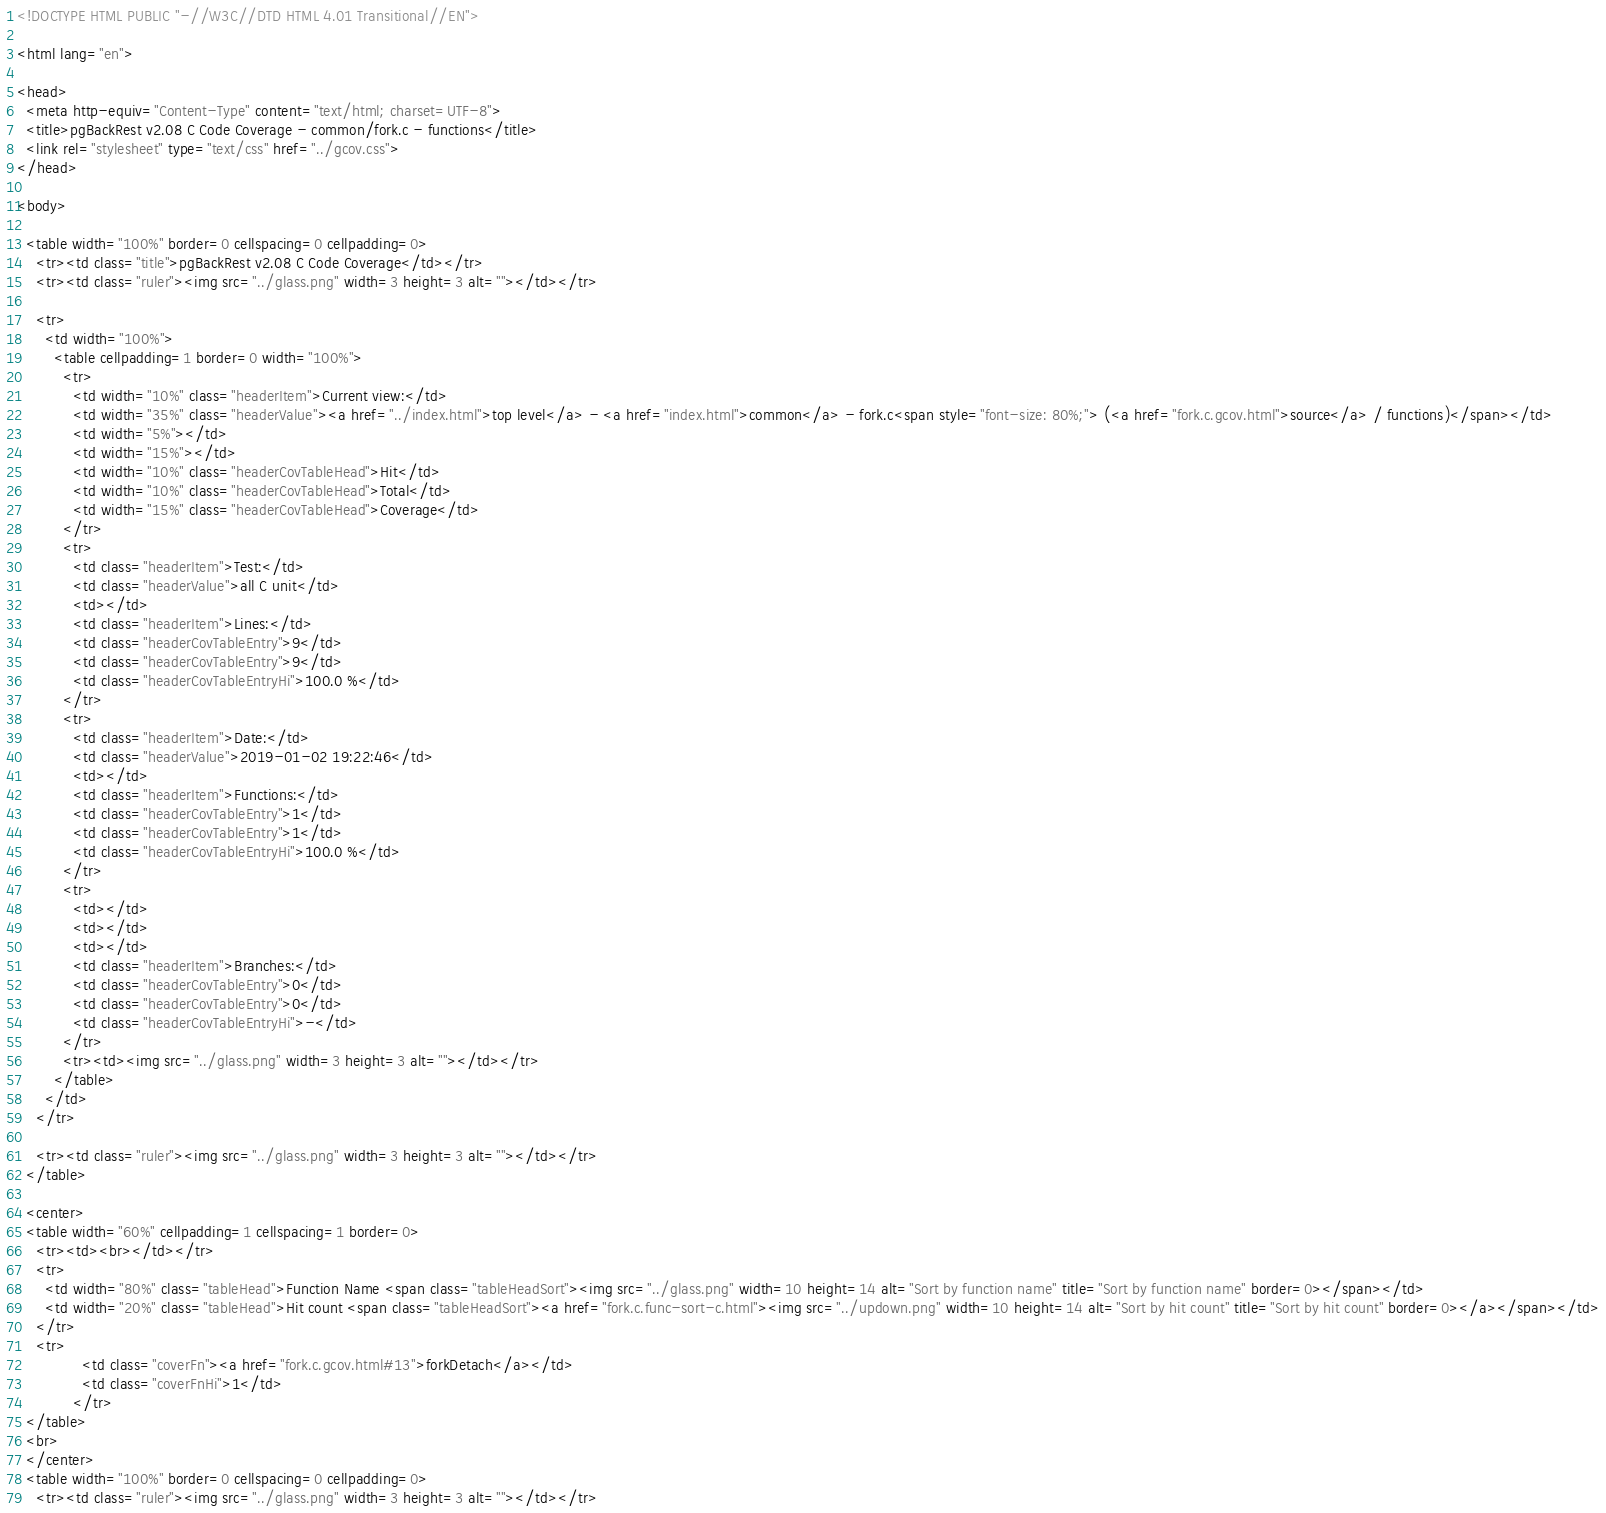Convert code to text. <code><loc_0><loc_0><loc_500><loc_500><_HTML_><!DOCTYPE HTML PUBLIC "-//W3C//DTD HTML 4.01 Transitional//EN">

<html lang="en">

<head>
  <meta http-equiv="Content-Type" content="text/html; charset=UTF-8">
  <title>pgBackRest v2.08 C Code Coverage - common/fork.c - functions</title>
  <link rel="stylesheet" type="text/css" href="../gcov.css">
</head>

<body>

  <table width="100%" border=0 cellspacing=0 cellpadding=0>
    <tr><td class="title">pgBackRest v2.08 C Code Coverage</td></tr>
    <tr><td class="ruler"><img src="../glass.png" width=3 height=3 alt=""></td></tr>

    <tr>
      <td width="100%">
        <table cellpadding=1 border=0 width="100%">
          <tr>
            <td width="10%" class="headerItem">Current view:</td>
            <td width="35%" class="headerValue"><a href="../index.html">top level</a> - <a href="index.html">common</a> - fork.c<span style="font-size: 80%;"> (<a href="fork.c.gcov.html">source</a> / functions)</span></td>
            <td width="5%"></td>
            <td width="15%"></td>
            <td width="10%" class="headerCovTableHead">Hit</td>
            <td width="10%" class="headerCovTableHead">Total</td>
            <td width="15%" class="headerCovTableHead">Coverage</td>
          </tr>
          <tr>
            <td class="headerItem">Test:</td>
            <td class="headerValue">all C unit</td>
            <td></td>
            <td class="headerItem">Lines:</td>
            <td class="headerCovTableEntry">9</td>
            <td class="headerCovTableEntry">9</td>
            <td class="headerCovTableEntryHi">100.0 %</td>
          </tr>
          <tr>
            <td class="headerItem">Date:</td>
            <td class="headerValue">2019-01-02 19:22:46</td>
            <td></td>
            <td class="headerItem">Functions:</td>
            <td class="headerCovTableEntry">1</td>
            <td class="headerCovTableEntry">1</td>
            <td class="headerCovTableEntryHi">100.0 %</td>
          </tr>
          <tr>
            <td></td>
            <td></td>
            <td></td>
            <td class="headerItem">Branches:</td>
            <td class="headerCovTableEntry">0</td>
            <td class="headerCovTableEntry">0</td>
            <td class="headerCovTableEntryHi">-</td>
          </tr>
          <tr><td><img src="../glass.png" width=3 height=3 alt=""></td></tr>
        </table>
      </td>
    </tr>

    <tr><td class="ruler"><img src="../glass.png" width=3 height=3 alt=""></td></tr>
  </table>

  <center>
  <table width="60%" cellpadding=1 cellspacing=1 border=0>
    <tr><td><br></td></tr>
    <tr>
      <td width="80%" class="tableHead">Function Name <span class="tableHeadSort"><img src="../glass.png" width=10 height=14 alt="Sort by function name" title="Sort by function name" border=0></span></td>
      <td width="20%" class="tableHead">Hit count <span class="tableHeadSort"><a href="fork.c.func-sort-c.html"><img src="../updown.png" width=10 height=14 alt="Sort by hit count" title="Sort by hit count" border=0></a></span></td>
    </tr>
    <tr>
              <td class="coverFn"><a href="fork.c.gcov.html#13">forkDetach</a></td>
              <td class="coverFnHi">1</td>
            </tr>
  </table>
  <br>
  </center>
  <table width="100%" border=0 cellspacing=0 cellpadding=0>
    <tr><td class="ruler"><img src="../glass.png" width=3 height=3 alt=""></td></tr></code> 